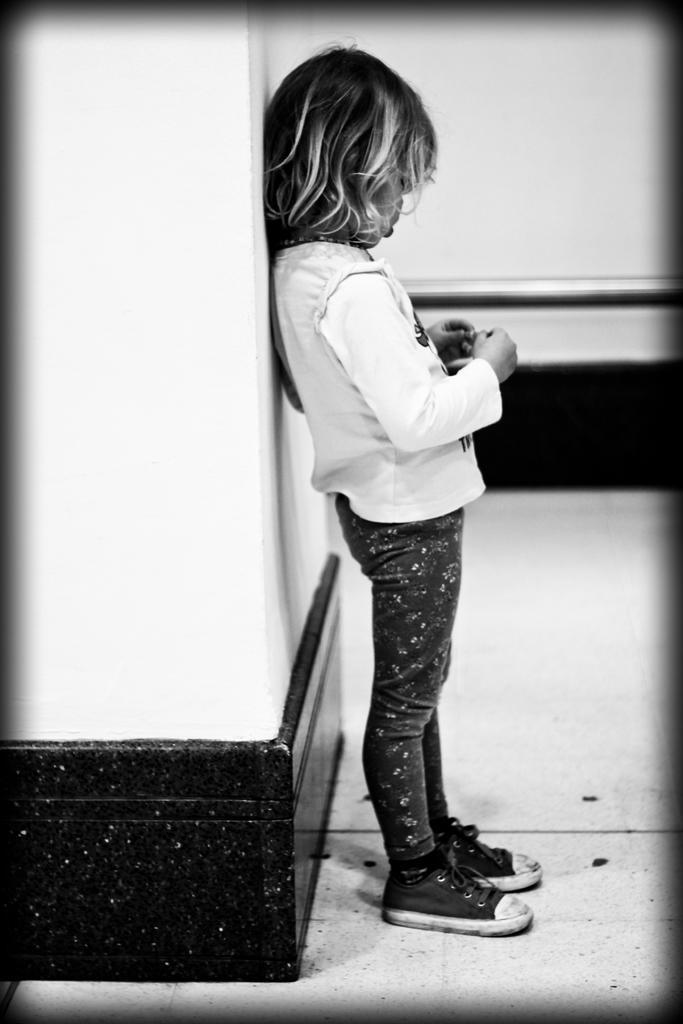Describe this image in one or two sentences. There is a girl standing, behind her we can see wall. 